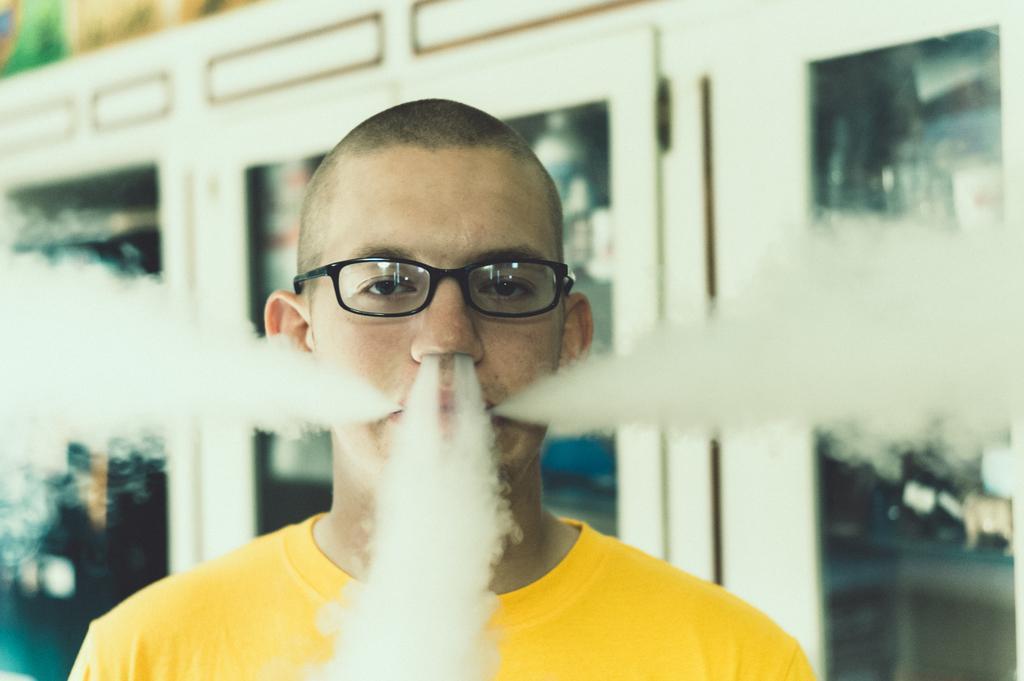Could you give a brief overview of what you see in this image? There is a smoke coming out from a person's nostrils and ears as we can see in the middle of this image, and there are some glass doors in the background. 